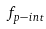Convert formula to latex. <formula><loc_0><loc_0><loc_500><loc_500>f _ { p - i n t }</formula> 